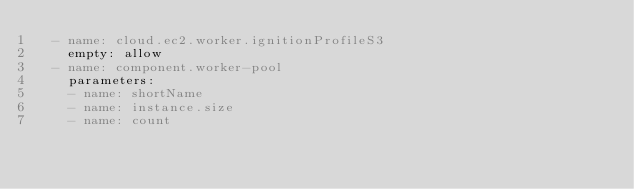Convert code to text. <code><loc_0><loc_0><loc_500><loc_500><_YAML_>  - name: cloud.ec2.worker.ignitionProfileS3
    empty: allow
  - name: component.worker-pool
    parameters:
    - name: shortName
    - name: instance.size
    - name: count
</code> 